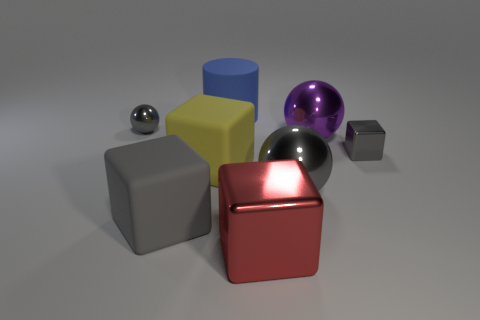Are there fewer big red shiny things that are behind the big blue cylinder than large gray objects that are behind the large purple metal object?
Provide a succinct answer. No. Is there a blue rubber thing of the same size as the purple object?
Offer a very short reply. Yes. Is the size of the gray block left of the cylinder the same as the blue matte object?
Your answer should be compact. Yes. Is the number of rubber blocks greater than the number of yellow things?
Give a very brief answer. Yes. Are there any big purple things that have the same shape as the red object?
Ensure brevity in your answer.  No. The tiny thing that is left of the large blue matte thing has what shape?
Your answer should be compact. Sphere. What number of big matte blocks are in front of the tiny shiny thing that is on the left side of the shiny cube behind the big gray shiny ball?
Provide a succinct answer. 2. There is a large metal sphere that is in front of the yellow object; is its color the same as the big shiny block?
Your answer should be compact. No. What number of other things are there of the same shape as the large purple thing?
Give a very brief answer. 2. How many other things are there of the same material as the large blue thing?
Your answer should be very brief. 2. 